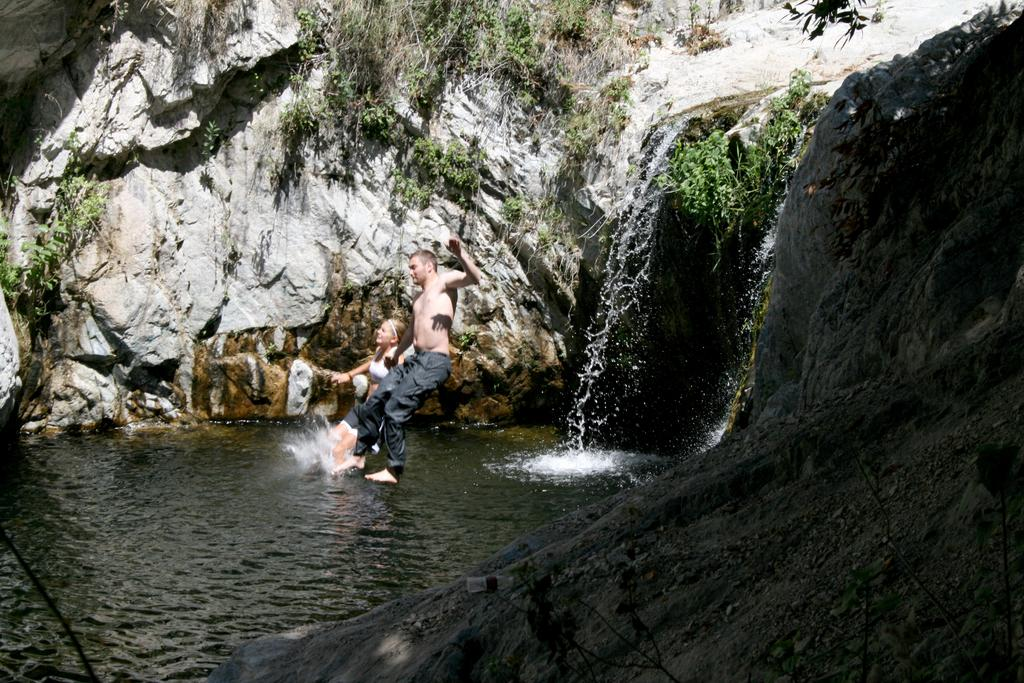How many people are in the image? There are two persons in the image. What are the persons doing in the image? The persons are jumping into the water. What natural feature is present in the image? There is a waterfall in the image. Where does the waterfall originate from? The waterfall is coming from a hill. What type of vegetation can be seen in the image? There are plants in the image. What time does the clock show in the image? There is no clock present in the image. How many geese are swimming in the water near the waterfall? There are no geese present in the image; it only features two people jumping into the water and a waterfall coming from a hill. 